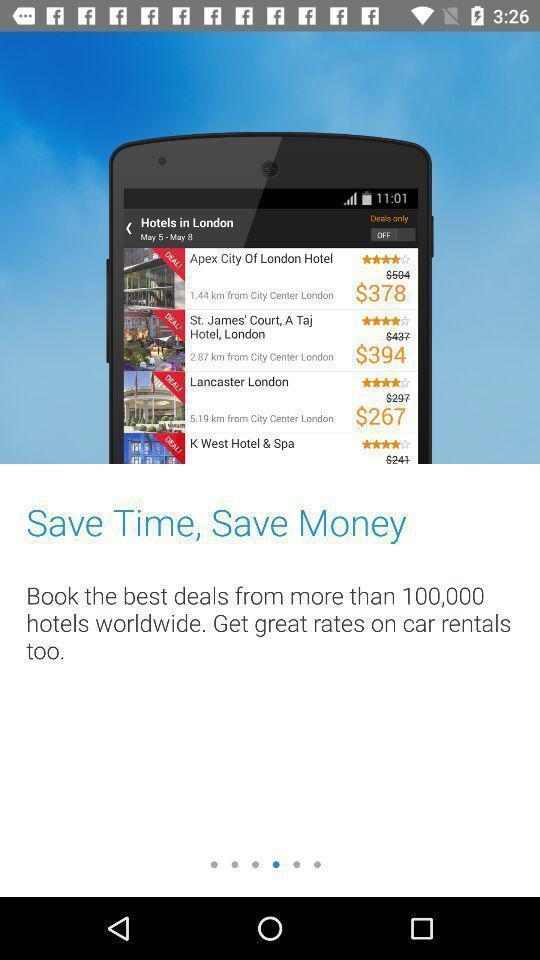Explain the elements present in this screenshot. Starting page. 